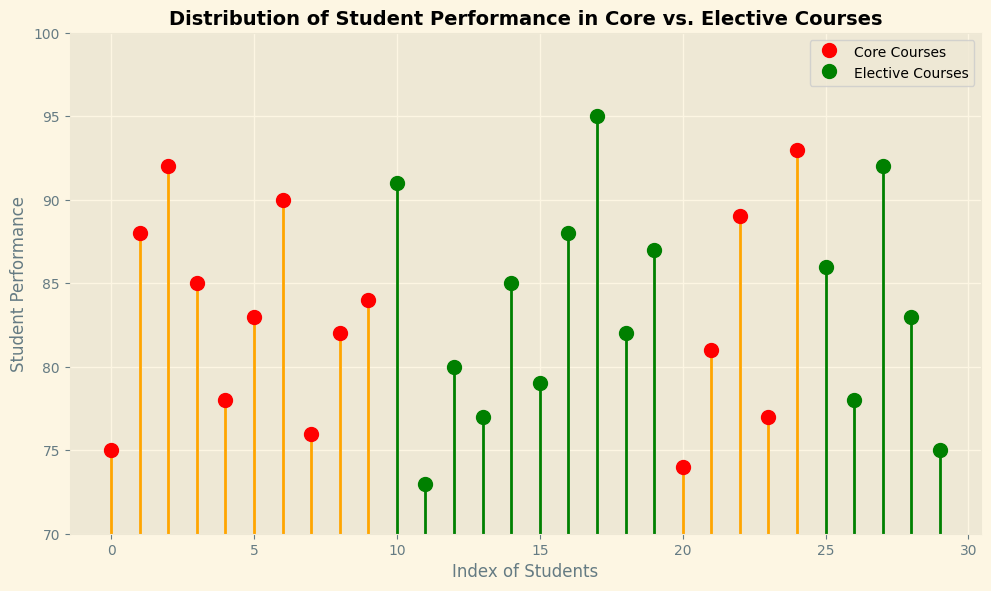Which course type has the highest performance score? The stem plot shows that the highest performance score for Core courses is 93, while for Elective courses, it is 95. Therefore, Elective courses have the highest performance score.
Answer: Elective courses Which group has more students scoring above 85? By counting the stem plot marks above 85, we see 4 Core students (88, 89, 92, 93) and 5 Elective students (86, 87, 88, 91, 92, 95). Thus, Elective courses have more students scoring above 85.
Answer: Elective courses What's the average performance score for Core courses? To find the average, sum all Core performance scores and divide by the count: (75 + 88 + 92 + 85 + 78 + 83 + 90 + 76 + 82 + 84 + 74 + 81 + 89 + 77 + 93) / 15 = 1257 / 15.
Answer: 83.8 How many more students in Elective courses scored above 80 compared to Core courses? Counting students scoring above 80 in both groups: Elective has 8 (82, 83, 85, 86, 87, 88, 91, 92, 95), Core has 9 (81, 82, 83, 84, 85, 88, 89, 90, 92, 93). So, Core has 1 more.
Answer: Core courses, 1 more What is the performance range for Core courses? The performance range is the difference between the highest and lowest scores. For Core courses, the range is 93 (highest) - 74 (lowest).
Answer: 19 Which course type has a more consistent performance indicated by less spread? Assessing the spread visually, Core courses appear more tightly clustered between 74 to 93, while Elective courses range from 73 to 95. Thus, Core courses have less spread.
Answer: Core courses Which course type scores above 90 more frequently? By examining the stem plot, Elective courses have three scores above 90 (91, 92, 95) and Core courses have three (92, 93). Both have the equal occurrences.
Answer: Both Are there more Core or Elective courses above the median performance of 85? The median of 85 separates the data at this score. Counting above 85, Core has 8 (88, 89, 90, 92, and 93), and Electives has 6 (86, 87, 88, 91, 92, 95). So, Core has more.
Answer: Core courses What is the lowest performance score in Elective courses? By observing the stem plot, the lowest mark for Elective courses is clearly a performance score of 73.
Answer: 73 